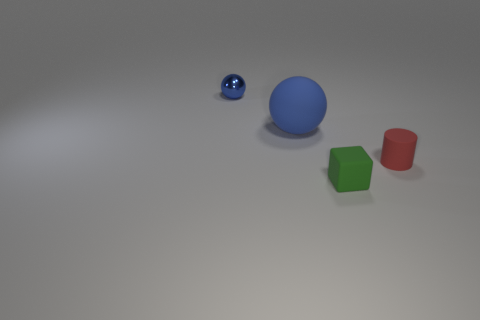Are there any other things that are made of the same material as the small sphere?
Your answer should be compact. No. There is a tiny matte object behind the tiny cube; does it have the same color as the sphere that is to the right of the metallic object?
Your response must be concise. No. Are there more red matte cylinders that are behind the tiny blue object than big blue matte objects?
Offer a very short reply. No. What number of other things are the same color as the tiny cube?
Ensure brevity in your answer.  0. Is the size of the thing on the right side of the green rubber cube the same as the large blue matte thing?
Offer a terse response. No. Are there any red matte things of the same size as the rubber block?
Your answer should be compact. Yes. There is a small rubber thing right of the green object; what color is it?
Give a very brief answer. Red. What is the shape of the object that is in front of the tiny blue metal sphere and on the left side of the tiny block?
Offer a terse response. Sphere. What number of tiny matte things have the same shape as the large blue object?
Your answer should be very brief. 0. What number of small green objects are there?
Offer a terse response. 1. 